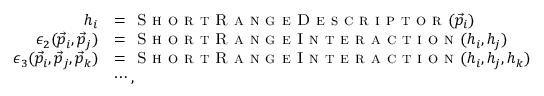Convert formula to latex. <formula><loc_0><loc_0><loc_500><loc_500>\begin{array} { r l } { h _ { i } } & { = S h o r t R a n g e D e s c r i p t o r ( \vec { p } _ { i } ) } \\ { \epsilon _ { 2 } ( \vec { p } _ { i } , \vec { p } _ { j } ) } & { = S h o r t R a n g e I n t e r a c t i o n ( h _ { i } , h _ { j } ) } \\ { \epsilon _ { 3 } ( \vec { p } _ { i } , \vec { p } _ { j } , \vec { p } _ { k } ) } & { = S h o r t R a n g e I n t e r a c t i o n ( h _ { i } , h _ { j } , h _ { k } ) } \\ & { \cdots , } \end{array}</formula> 